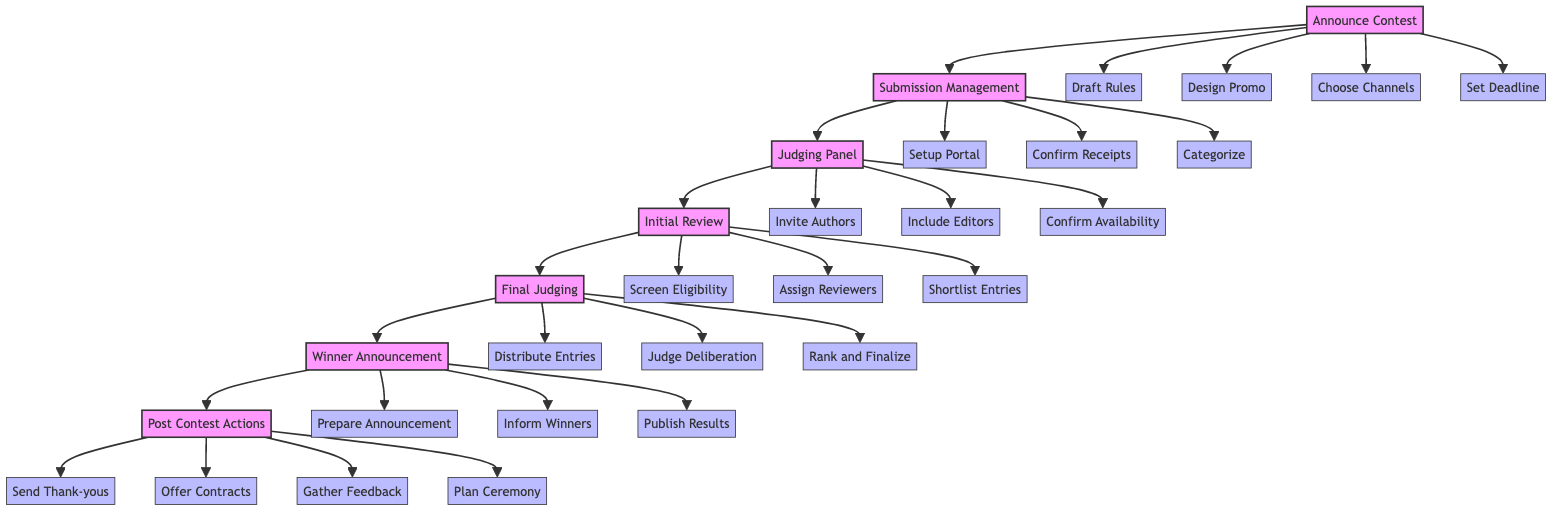What is the first task in the flowchart? The first task in the flowchart is "Announce Contest", which is depicted at the top of the flowchart as the starting point.
Answer: Announce Contest How many main tasks are there in the contest organization process? The flowchart outlines a total of six main tasks: Announce Contest, Submission Management, Judging Panel, Initial Review, Final Judging, and Winner Announcement, culminating in Post Contest Actions.
Answer: Six What follows the Judging Panel in the flowchart? After the Judging Panel task, the next task is the Initial Review. This can be traced visually by following the directional arrows from the Judging Panel node.
Answer: Initial Review Which task includes sending thank-you notes? The task that includes sending thank-you notes is labeled "Post Contest Actions." This is determined by looking at the flowchart's final task that includes follow-up activities.
Answer: Post Contest Actions Which subtask is associated with the task 'Submission Management'? The subtasks connected to the 'Submission Management' task include "Set Up Submission Portal", "Confirm Receipt of Submissions", and "Categorize By Age Group or Theme". These are directly linked below the 'Submission Management' node.
Answer: Set Up Submission Portal What is the relationship between 'Initial Review' and 'Final Judging'? The relationship is sequential; the 'Initial Review' task directly leads to the 'Final Judging' task in a linear progression indicated by the arrow connecting them.
Answer: Sequential How many subtasks are there under 'Winner Announcement'? Under 'Winner Announcement', there are three subtasks listed: "Prepare Winner Announcement Materials", "Inform Winners Privately", and "Publish Winners on Promotion Channels", totaling three subtasks.
Answer: Three What do judges do during the 'Final Judging' phase? During the 'Final Judging' phase, judges "Distribute Shortlisted Entries", "Conduct Judge Deliberation Meetings", and "Rank Entries and Finalize Winners", which directly outlines their activities.
Answer: Rank Entries and Finalize Winners Which task is related to gathering feedback? The task related to gathering feedback is 'Post Contest Actions’, which includes the subtask to "Gather Feedback for Future Contests" as part of the follow-up activities.
Answer: Post Contest Actions 